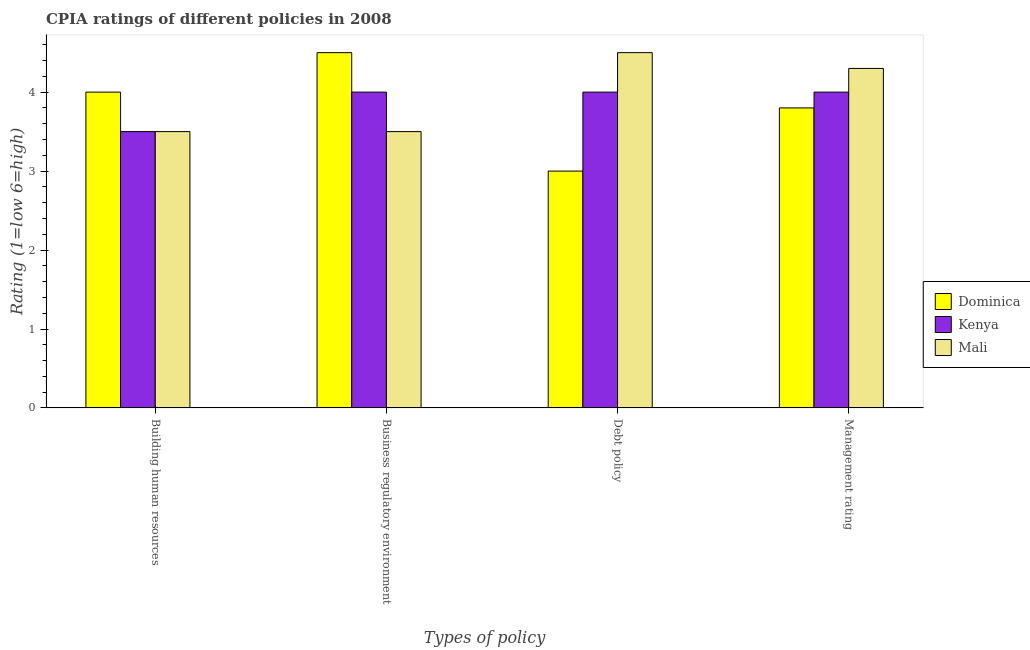Are the number of bars per tick equal to the number of legend labels?
Your answer should be very brief. Yes. How many bars are there on the 1st tick from the left?
Offer a very short reply. 3. How many bars are there on the 1st tick from the right?
Your answer should be compact. 3. What is the label of the 4th group of bars from the left?
Offer a terse response. Management rating. Across all countries, what is the maximum cpia rating of debt policy?
Give a very brief answer. 4.5. In which country was the cpia rating of management maximum?
Provide a short and direct response. Mali. In which country was the cpia rating of management minimum?
Provide a short and direct response. Dominica. What is the difference between the cpia rating of business regulatory environment in Kenya and that in Dominica?
Your answer should be compact. -0.5. What is the difference between the cpia rating of building human resources in Mali and the cpia rating of business regulatory environment in Dominica?
Provide a short and direct response. -1. What is the difference between the cpia rating of debt policy and cpia rating of business regulatory environment in Mali?
Offer a very short reply. 1. In how many countries, is the cpia rating of debt policy greater than 1.4 ?
Provide a short and direct response. 3. What is the ratio of the cpia rating of building human resources in Dominica to that in Mali?
Offer a very short reply. 1.14. Is the cpia rating of building human resources in Kenya less than that in Mali?
Keep it short and to the point. No. What is the difference between the highest and the second highest cpia rating of management?
Your answer should be compact. 0.3. What is the difference between the highest and the lowest cpia rating of debt policy?
Ensure brevity in your answer.  1.5. Is the sum of the cpia rating of business regulatory environment in Kenya and Mali greater than the maximum cpia rating of management across all countries?
Provide a succinct answer. Yes. Is it the case that in every country, the sum of the cpia rating of building human resources and cpia rating of debt policy is greater than the sum of cpia rating of business regulatory environment and cpia rating of management?
Keep it short and to the point. No. What does the 3rd bar from the left in Business regulatory environment represents?
Your answer should be compact. Mali. What does the 1st bar from the right in Debt policy represents?
Ensure brevity in your answer.  Mali. Is it the case that in every country, the sum of the cpia rating of building human resources and cpia rating of business regulatory environment is greater than the cpia rating of debt policy?
Offer a very short reply. Yes. Are all the bars in the graph horizontal?
Offer a terse response. No. How many countries are there in the graph?
Keep it short and to the point. 3. Are the values on the major ticks of Y-axis written in scientific E-notation?
Provide a succinct answer. No. Does the graph contain any zero values?
Offer a very short reply. No. Does the graph contain grids?
Give a very brief answer. No. Where does the legend appear in the graph?
Your answer should be very brief. Center right. What is the title of the graph?
Keep it short and to the point. CPIA ratings of different policies in 2008. What is the label or title of the X-axis?
Ensure brevity in your answer.  Types of policy. What is the label or title of the Y-axis?
Provide a succinct answer. Rating (1=low 6=high). What is the Rating (1=low 6=high) in Dominica in Business regulatory environment?
Ensure brevity in your answer.  4.5. What is the Rating (1=low 6=high) of Kenya in Debt policy?
Keep it short and to the point. 4. What is the Rating (1=low 6=high) in Dominica in Management rating?
Offer a very short reply. 3.8. Across all Types of policy, what is the maximum Rating (1=low 6=high) of Kenya?
Provide a short and direct response. 4. Across all Types of policy, what is the maximum Rating (1=low 6=high) of Mali?
Offer a terse response. 4.5. What is the total Rating (1=low 6=high) of Dominica in the graph?
Ensure brevity in your answer.  15.3. What is the total Rating (1=low 6=high) in Mali in the graph?
Give a very brief answer. 15.8. What is the difference between the Rating (1=low 6=high) of Dominica in Building human resources and that in Business regulatory environment?
Provide a short and direct response. -0.5. What is the difference between the Rating (1=low 6=high) in Kenya in Building human resources and that in Business regulatory environment?
Provide a short and direct response. -0.5. What is the difference between the Rating (1=low 6=high) in Dominica in Building human resources and that in Management rating?
Make the answer very short. 0.2. What is the difference between the Rating (1=low 6=high) of Kenya in Building human resources and that in Management rating?
Offer a terse response. -0.5. What is the difference between the Rating (1=low 6=high) in Dominica in Business regulatory environment and that in Debt policy?
Your answer should be very brief. 1.5. What is the difference between the Rating (1=low 6=high) of Mali in Business regulatory environment and that in Debt policy?
Make the answer very short. -1. What is the difference between the Rating (1=low 6=high) in Dominica in Business regulatory environment and that in Management rating?
Offer a very short reply. 0.7. What is the difference between the Rating (1=low 6=high) in Kenya in Business regulatory environment and that in Management rating?
Keep it short and to the point. 0. What is the difference between the Rating (1=low 6=high) in Mali in Business regulatory environment and that in Management rating?
Your answer should be very brief. -0.8. What is the difference between the Rating (1=low 6=high) of Kenya in Debt policy and that in Management rating?
Offer a terse response. 0. What is the difference between the Rating (1=low 6=high) in Mali in Debt policy and that in Management rating?
Ensure brevity in your answer.  0.2. What is the difference between the Rating (1=low 6=high) of Dominica in Building human resources and the Rating (1=low 6=high) of Kenya in Business regulatory environment?
Provide a short and direct response. 0. What is the difference between the Rating (1=low 6=high) in Kenya in Building human resources and the Rating (1=low 6=high) in Mali in Business regulatory environment?
Keep it short and to the point. 0. What is the difference between the Rating (1=low 6=high) of Kenya in Building human resources and the Rating (1=low 6=high) of Mali in Debt policy?
Your answer should be compact. -1. What is the difference between the Rating (1=low 6=high) of Dominica in Building human resources and the Rating (1=low 6=high) of Kenya in Management rating?
Give a very brief answer. 0. What is the difference between the Rating (1=low 6=high) in Kenya in Building human resources and the Rating (1=low 6=high) in Mali in Management rating?
Keep it short and to the point. -0.8. What is the difference between the Rating (1=low 6=high) of Kenya in Business regulatory environment and the Rating (1=low 6=high) of Mali in Management rating?
Provide a short and direct response. -0.3. What is the difference between the Rating (1=low 6=high) in Dominica in Debt policy and the Rating (1=low 6=high) in Mali in Management rating?
Provide a short and direct response. -1.3. What is the difference between the Rating (1=low 6=high) of Kenya in Debt policy and the Rating (1=low 6=high) of Mali in Management rating?
Make the answer very short. -0.3. What is the average Rating (1=low 6=high) of Dominica per Types of policy?
Ensure brevity in your answer.  3.83. What is the average Rating (1=low 6=high) of Kenya per Types of policy?
Your response must be concise. 3.88. What is the average Rating (1=low 6=high) in Mali per Types of policy?
Your answer should be very brief. 3.95. What is the difference between the Rating (1=low 6=high) in Dominica and Rating (1=low 6=high) in Mali in Building human resources?
Provide a succinct answer. 0.5. What is the difference between the Rating (1=low 6=high) of Kenya and Rating (1=low 6=high) of Mali in Building human resources?
Your answer should be very brief. 0. What is the difference between the Rating (1=low 6=high) of Dominica and Rating (1=low 6=high) of Kenya in Business regulatory environment?
Make the answer very short. 0.5. What is the difference between the Rating (1=low 6=high) of Kenya and Rating (1=low 6=high) of Mali in Debt policy?
Give a very brief answer. -0.5. What is the difference between the Rating (1=low 6=high) of Dominica and Rating (1=low 6=high) of Mali in Management rating?
Make the answer very short. -0.5. What is the difference between the Rating (1=low 6=high) of Kenya and Rating (1=low 6=high) of Mali in Management rating?
Give a very brief answer. -0.3. What is the ratio of the Rating (1=low 6=high) in Mali in Building human resources to that in Business regulatory environment?
Keep it short and to the point. 1. What is the ratio of the Rating (1=low 6=high) of Dominica in Building human resources to that in Debt policy?
Provide a short and direct response. 1.33. What is the ratio of the Rating (1=low 6=high) in Dominica in Building human resources to that in Management rating?
Offer a very short reply. 1.05. What is the ratio of the Rating (1=low 6=high) in Kenya in Building human resources to that in Management rating?
Make the answer very short. 0.88. What is the ratio of the Rating (1=low 6=high) of Mali in Building human resources to that in Management rating?
Offer a very short reply. 0.81. What is the ratio of the Rating (1=low 6=high) in Mali in Business regulatory environment to that in Debt policy?
Keep it short and to the point. 0.78. What is the ratio of the Rating (1=low 6=high) of Dominica in Business regulatory environment to that in Management rating?
Provide a short and direct response. 1.18. What is the ratio of the Rating (1=low 6=high) in Mali in Business regulatory environment to that in Management rating?
Your answer should be compact. 0.81. What is the ratio of the Rating (1=low 6=high) of Dominica in Debt policy to that in Management rating?
Your response must be concise. 0.79. What is the ratio of the Rating (1=low 6=high) in Kenya in Debt policy to that in Management rating?
Keep it short and to the point. 1. What is the ratio of the Rating (1=low 6=high) of Mali in Debt policy to that in Management rating?
Give a very brief answer. 1.05. What is the difference between the highest and the second highest Rating (1=low 6=high) of Dominica?
Give a very brief answer. 0.5. What is the difference between the highest and the second highest Rating (1=low 6=high) of Kenya?
Your answer should be compact. 0. What is the difference between the highest and the second highest Rating (1=low 6=high) in Mali?
Your response must be concise. 0.2. What is the difference between the highest and the lowest Rating (1=low 6=high) of Dominica?
Your response must be concise. 1.5. What is the difference between the highest and the lowest Rating (1=low 6=high) of Kenya?
Provide a succinct answer. 0.5. What is the difference between the highest and the lowest Rating (1=low 6=high) of Mali?
Your response must be concise. 1. 